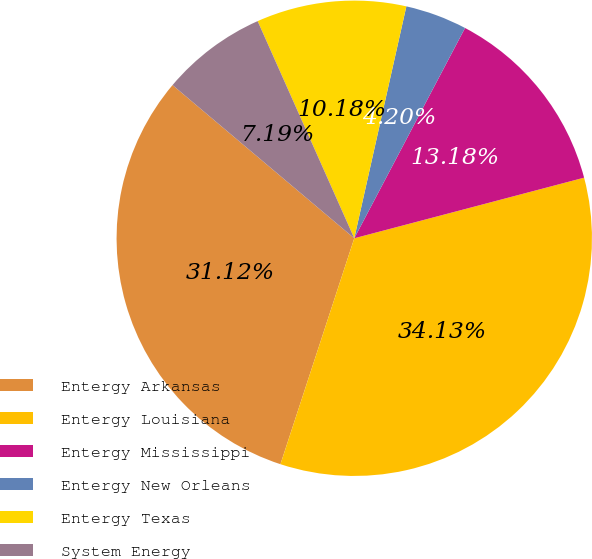<chart> <loc_0><loc_0><loc_500><loc_500><pie_chart><fcel>Entergy Arkansas<fcel>Entergy Louisiana<fcel>Entergy Mississippi<fcel>Entergy New Orleans<fcel>Entergy Texas<fcel>System Energy<nl><fcel>31.12%<fcel>34.13%<fcel>13.18%<fcel>4.2%<fcel>10.18%<fcel>7.19%<nl></chart> 